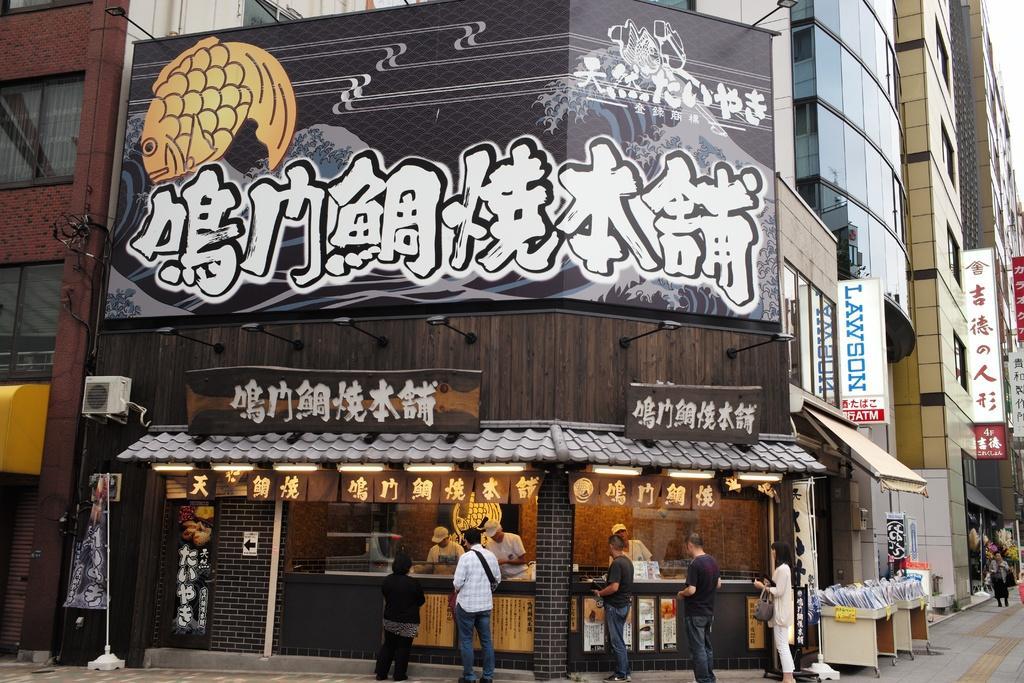Please provide a concise description of this image. In this image there are buildings, there are boards on the buildings, there is text on the boards, there are windows, there are persons standing, there are objects on the ground, there is a pole, there is a flag. 